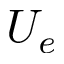<formula> <loc_0><loc_0><loc_500><loc_500>U _ { e }</formula> 